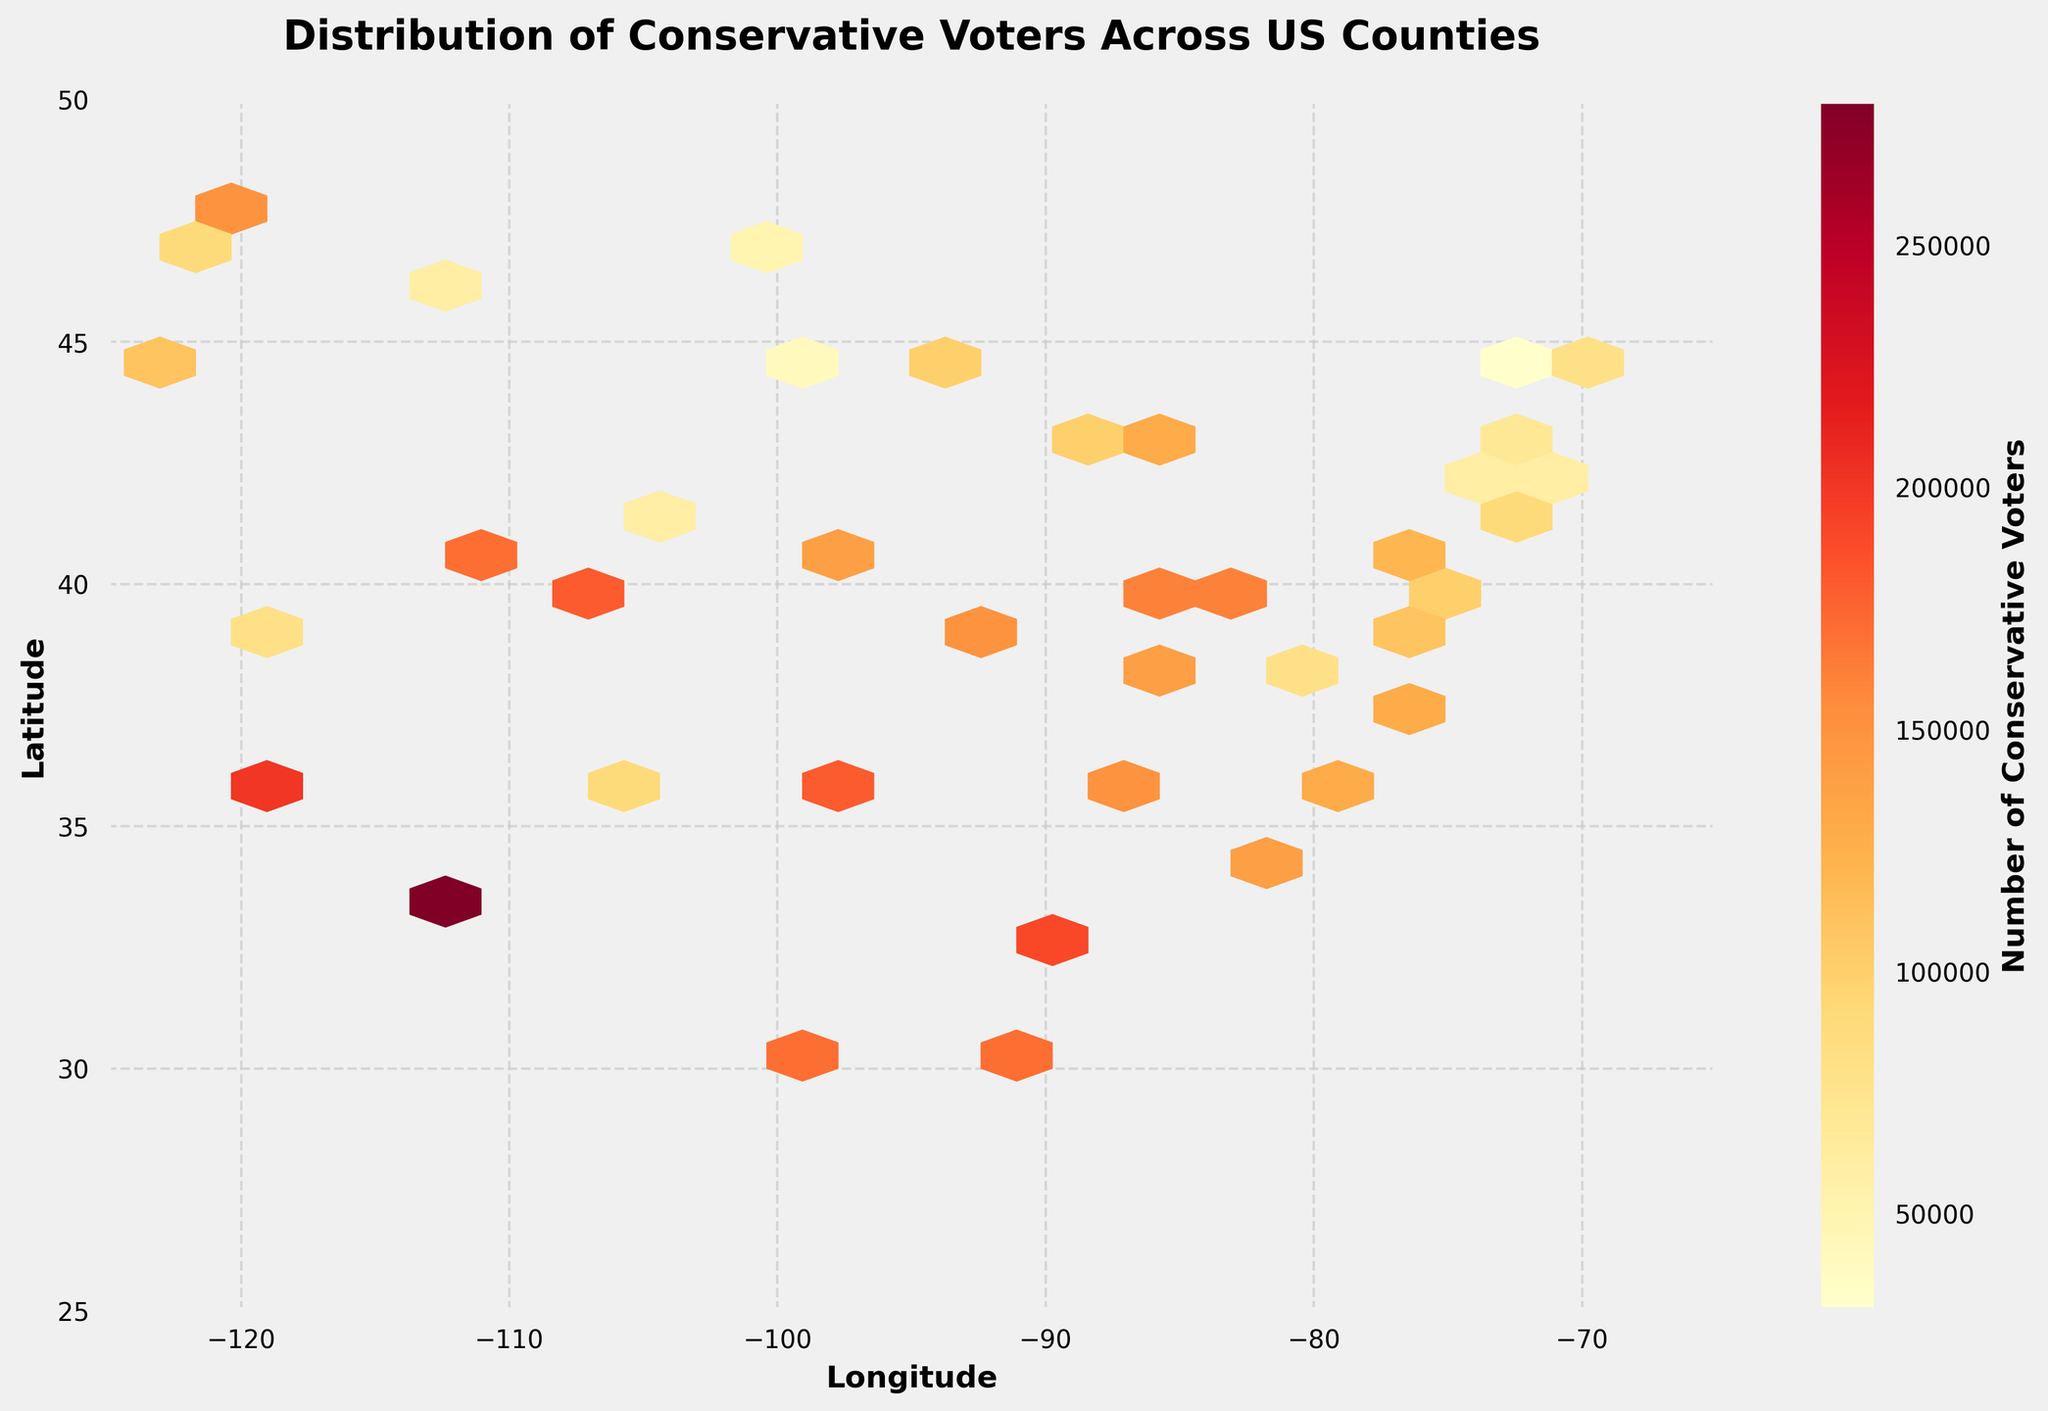What is the title of the plot? The title is located at the top of the plot. It usually provides a brief description of the plot's content. In this case, the title is "Distribution of Conservative Voters Across US Counties".
Answer: Distribution of Conservative Voters Across US Counties What is the range of latitude and longitude covered in the plot? The axes of the plot show the range of latitude and longitude. The latitude ranges from approximately 25 to 50 degrees, and the longitude ranges from around -125 to -65 degrees.
Answer: Latitude: 25 to 50, Longitude: -125 to -65 Which area of the United States has the highest concentration of conservative voters? The color density in a hexbin plot indicates concentration levels. The darkest (reddest) areas on the plot represent the highest concentration. The highest concentration of conservative voters appears to be in the southeastern region of the United States.
Answer: Southeastern US What does the color bar next to the plot represent? The color bar, typically a gradient of colors from light to dark, indicates the number of conservative voters. The label of the color bar reads "Number of Conservative Voters".
Answer: Number of Conservative Voters Are there any areas with noticeably low concentrations of conservative voters? By looking at the lightest color regions in the plot, one can identify areas with the fewest conservative voters. The northeastern US and parts of the western US appear to have noticeably low concentrations.
Answer: Northeastern and Western US Which state appears to have a significant number of conservative voters spread over multiple counties? States with multiple dark hexagons indicate a significant number of conservative voters across various counties. Texas and California both seem to have several counties with significant conservative voter concentrations.
Answer: Texas and California How does the concentration of conservative voters in the Midwest compare to that in the Northeast? The color intensity, which shows voter concentration, can be compared between the two regions. The Midwest shows a higher concentration with more dark hexagons compared to the Northeast, which has relatively lighter hexagons.
Answer: Higher in the Midwest What unique patterns can be interpreted from the plot regarding conservative voter distribution? Patterns in a hexbin plot can inform us about concentrations and dispersals. One unique pattern is the high concentration in the South and Midwest, with sparser distributions in the Northeast and Far West.
Answer: High in South and Midwest; sparse in Northeast and Far West 